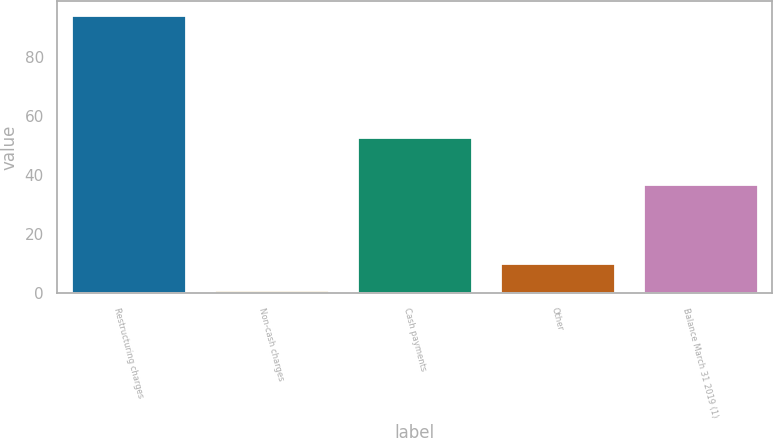Convert chart. <chart><loc_0><loc_0><loc_500><loc_500><bar_chart><fcel>Restructuring charges<fcel>Non-cash charges<fcel>Cash payments<fcel>Other<fcel>Balance March 31 2019 (1)<nl><fcel>94<fcel>1<fcel>53<fcel>10.3<fcel>37<nl></chart> 